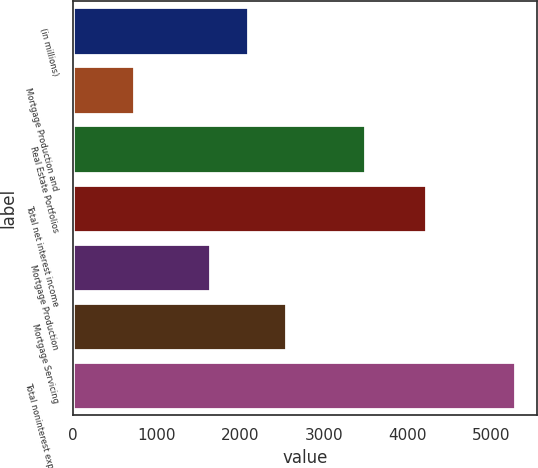Convert chart. <chart><loc_0><loc_0><loc_500><loc_500><bar_chart><fcel>(in millions)<fcel>Mortgage Production and<fcel>Real Estate Portfolios<fcel>Total net interest income<fcel>Mortgage Production<fcel>Mortgage Servicing<fcel>Total noninterest expense<nl><fcel>2098.8<fcel>736<fcel>3493<fcel>4229<fcel>1644<fcel>2553.6<fcel>5284<nl></chart> 